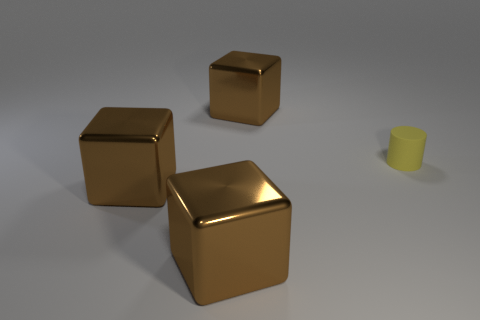Add 3 tiny cylinders. How many objects exist? 7 Subtract all blocks. How many objects are left? 1 Add 4 big yellow cubes. How many big yellow cubes exist? 4 Subtract 0 purple balls. How many objects are left? 4 Subtract all large brown metal objects. Subtract all small cylinders. How many objects are left? 0 Add 1 large brown cubes. How many large brown cubes are left? 4 